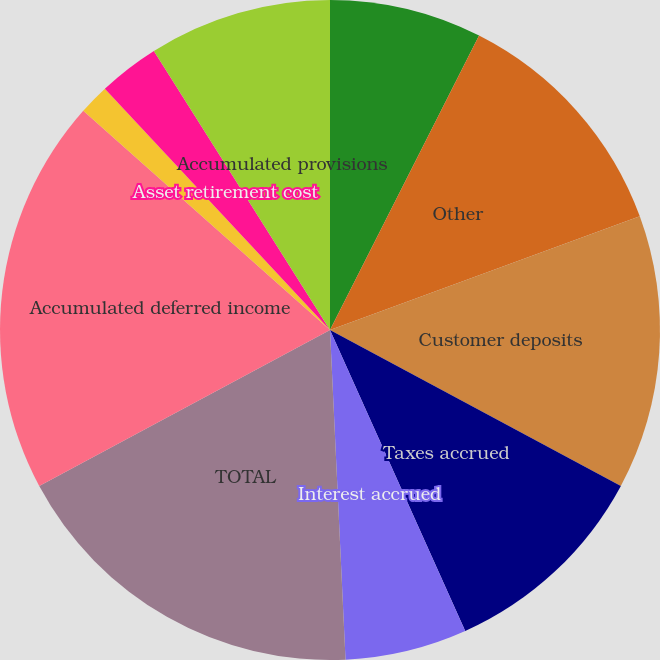Convert chart. <chart><loc_0><loc_0><loc_500><loc_500><pie_chart><fcel>Associated companies<fcel>Other<fcel>Customer deposits<fcel>Taxes accrued<fcel>Interest accrued<fcel>TOTAL<fcel>Accumulated deferred income<fcel>Accumulated deferred<fcel>Asset retirement cost<fcel>Accumulated provisions<nl><fcel>7.46%<fcel>11.94%<fcel>13.43%<fcel>10.45%<fcel>5.97%<fcel>17.91%<fcel>19.4%<fcel>1.49%<fcel>2.99%<fcel>8.96%<nl></chart> 